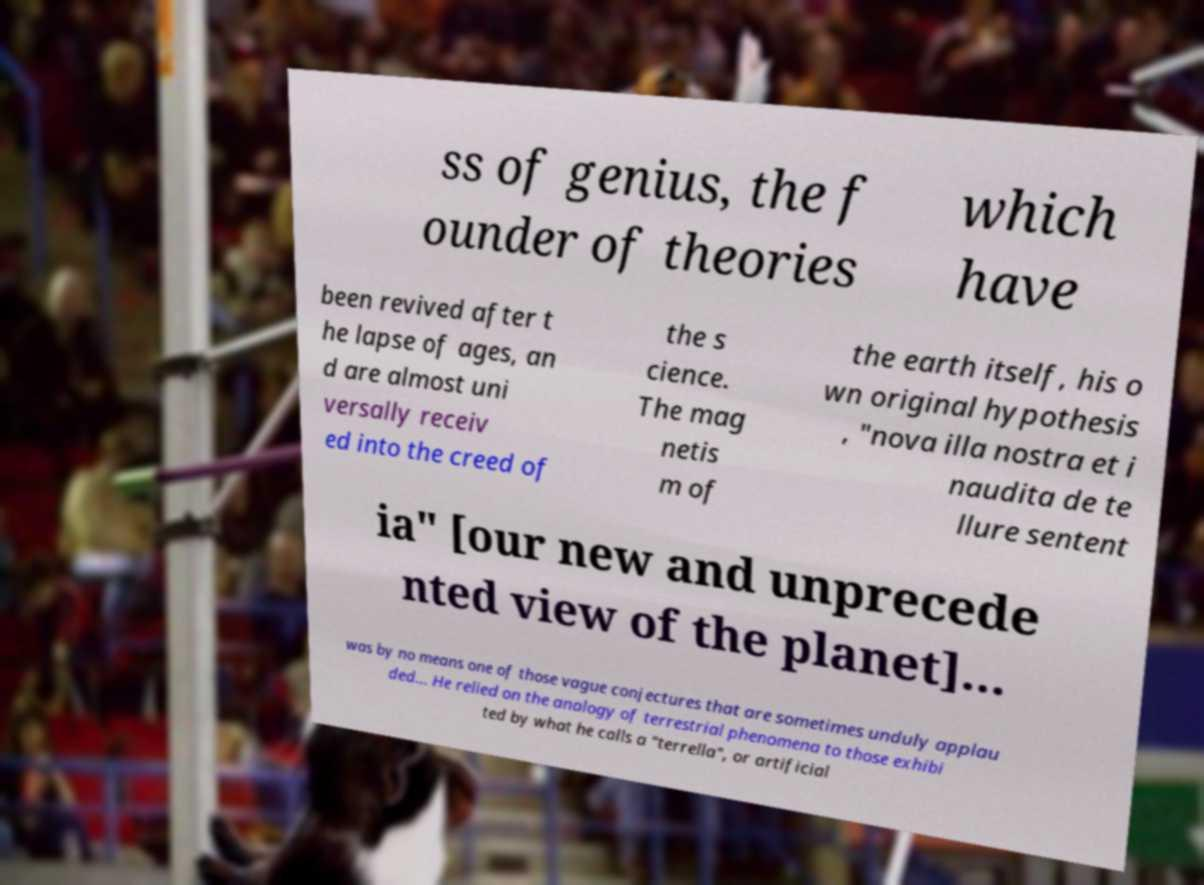I need the written content from this picture converted into text. Can you do that? ss of genius, the f ounder of theories which have been revived after t he lapse of ages, an d are almost uni versally receiv ed into the creed of the s cience. The mag netis m of the earth itself, his o wn original hypothesis , "nova illa nostra et i naudita de te llure sentent ia" [our new and unprecede nted view of the planet]... was by no means one of those vague conjectures that are sometimes unduly applau ded... He relied on the analogy of terrestrial phenomena to those exhibi ted by what he calls a "terrella", or artificial 